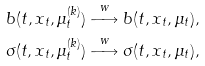<formula> <loc_0><loc_0><loc_500><loc_500>b ( t , x _ { t } , \mu _ { t } ^ { ( k ) } ) \stackrel { w } \longrightarrow b ( t , x _ { t } , \mu _ { t } ) , \\ \sigma ( t , x _ { t } , \mu _ { t } ^ { ( k ) } ) \stackrel { w } \longrightarrow \sigma ( t , x _ { t } , \mu _ { t } ) ,</formula> 